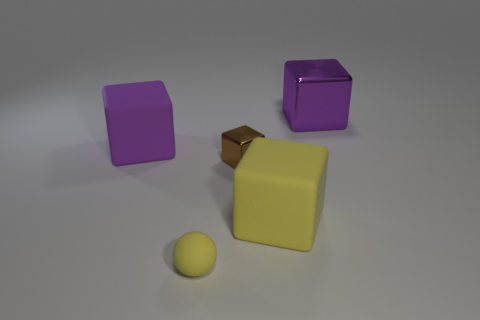Subtract all blue blocks. Subtract all cyan spheres. How many blocks are left? 4 Add 2 blue metal objects. How many objects exist? 7 Subtract all spheres. How many objects are left? 4 Subtract 0 cyan spheres. How many objects are left? 5 Subtract all gray things. Subtract all small rubber balls. How many objects are left? 4 Add 5 yellow things. How many yellow things are left? 7 Add 4 yellow things. How many yellow things exist? 6 